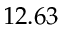Convert formula to latex. <formula><loc_0><loc_0><loc_500><loc_500>1 2 . 6 3</formula> 